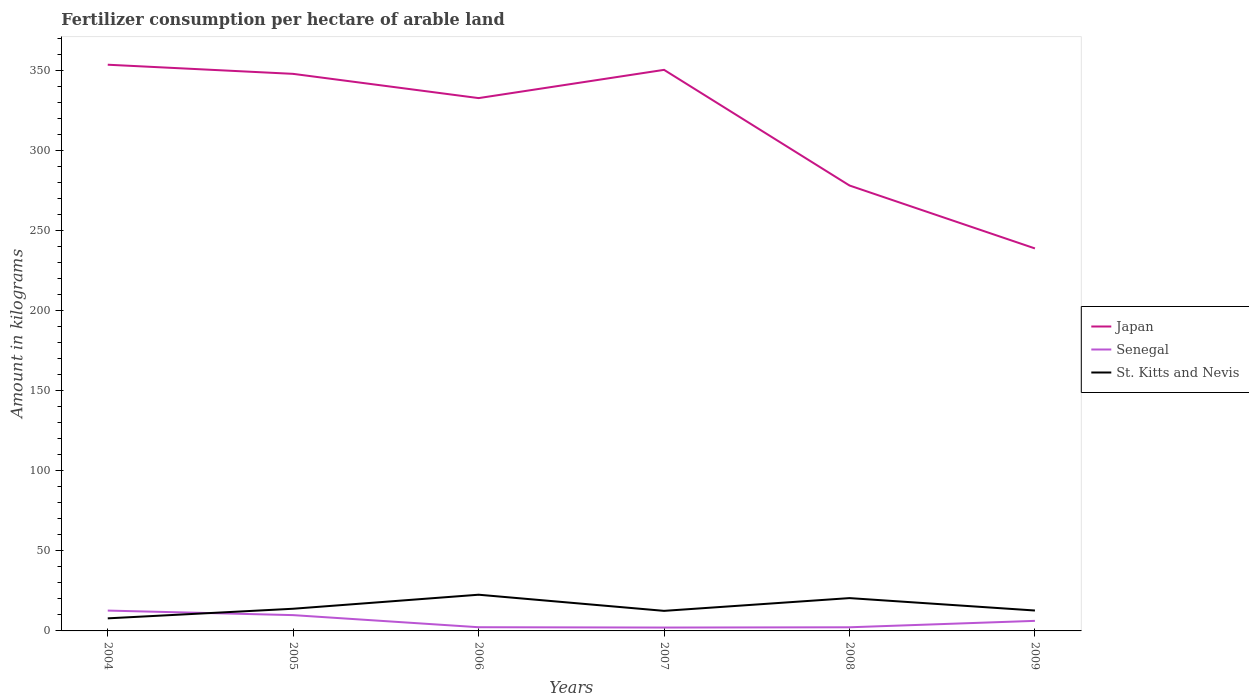Does the line corresponding to Japan intersect with the line corresponding to St. Kitts and Nevis?
Offer a very short reply. No. Across all years, what is the maximum amount of fertilizer consumption in Senegal?
Keep it short and to the point. 2.11. What is the total amount of fertilizer consumption in Senegal in the graph?
Offer a terse response. 3.58. What is the difference between the highest and the second highest amount of fertilizer consumption in St. Kitts and Nevis?
Your answer should be very brief. 14.76. How many years are there in the graph?
Your response must be concise. 6. What is the difference between two consecutive major ticks on the Y-axis?
Ensure brevity in your answer.  50. Are the values on the major ticks of Y-axis written in scientific E-notation?
Provide a succinct answer. No. Where does the legend appear in the graph?
Keep it short and to the point. Center right. How many legend labels are there?
Offer a very short reply. 3. What is the title of the graph?
Provide a succinct answer. Fertilizer consumption per hectare of arable land. Does "Chad" appear as one of the legend labels in the graph?
Keep it short and to the point. No. What is the label or title of the Y-axis?
Keep it short and to the point. Amount in kilograms. What is the Amount in kilograms of Japan in 2004?
Your answer should be compact. 353.68. What is the Amount in kilograms in Senegal in 2004?
Give a very brief answer. 12.71. What is the Amount in kilograms of St. Kitts and Nevis in 2004?
Give a very brief answer. 7.86. What is the Amount in kilograms of Japan in 2005?
Your answer should be very brief. 347.97. What is the Amount in kilograms in Senegal in 2005?
Your answer should be very brief. 9.87. What is the Amount in kilograms in St. Kitts and Nevis in 2005?
Keep it short and to the point. 13.85. What is the Amount in kilograms in Japan in 2006?
Your response must be concise. 332.83. What is the Amount in kilograms in Senegal in 2006?
Keep it short and to the point. 2.31. What is the Amount in kilograms in St. Kitts and Nevis in 2006?
Give a very brief answer. 22.61. What is the Amount in kilograms in Japan in 2007?
Ensure brevity in your answer.  350.47. What is the Amount in kilograms of Senegal in 2007?
Provide a short and direct response. 2.11. What is the Amount in kilograms in St. Kitts and Nevis in 2007?
Your answer should be very brief. 12.53. What is the Amount in kilograms in Japan in 2008?
Keep it short and to the point. 278.23. What is the Amount in kilograms of Senegal in 2008?
Give a very brief answer. 2.27. What is the Amount in kilograms of Japan in 2009?
Provide a succinct answer. 238.93. What is the Amount in kilograms in Senegal in 2009?
Give a very brief answer. 6.29. What is the Amount in kilograms of St. Kitts and Nevis in 2009?
Keep it short and to the point. 12.75. Across all years, what is the maximum Amount in kilograms of Japan?
Provide a succinct answer. 353.68. Across all years, what is the maximum Amount in kilograms in Senegal?
Your response must be concise. 12.71. Across all years, what is the maximum Amount in kilograms of St. Kitts and Nevis?
Make the answer very short. 22.61. Across all years, what is the minimum Amount in kilograms in Japan?
Make the answer very short. 238.93. Across all years, what is the minimum Amount in kilograms of Senegal?
Ensure brevity in your answer.  2.11. Across all years, what is the minimum Amount in kilograms in St. Kitts and Nevis?
Keep it short and to the point. 7.86. What is the total Amount in kilograms of Japan in the graph?
Your response must be concise. 1902.11. What is the total Amount in kilograms in Senegal in the graph?
Provide a short and direct response. 35.56. What is the total Amount in kilograms in St. Kitts and Nevis in the graph?
Your answer should be compact. 90.11. What is the difference between the Amount in kilograms of Japan in 2004 and that in 2005?
Provide a succinct answer. 5.71. What is the difference between the Amount in kilograms in Senegal in 2004 and that in 2005?
Give a very brief answer. 2.85. What is the difference between the Amount in kilograms in St. Kitts and Nevis in 2004 and that in 2005?
Ensure brevity in your answer.  -6. What is the difference between the Amount in kilograms of Japan in 2004 and that in 2006?
Make the answer very short. 20.86. What is the difference between the Amount in kilograms of Senegal in 2004 and that in 2006?
Provide a short and direct response. 10.4. What is the difference between the Amount in kilograms in St. Kitts and Nevis in 2004 and that in 2006?
Make the answer very short. -14.76. What is the difference between the Amount in kilograms in Japan in 2004 and that in 2007?
Offer a terse response. 3.21. What is the difference between the Amount in kilograms of Senegal in 2004 and that in 2007?
Provide a succinct answer. 10.6. What is the difference between the Amount in kilograms in St. Kitts and Nevis in 2004 and that in 2007?
Give a very brief answer. -4.67. What is the difference between the Amount in kilograms in Japan in 2004 and that in 2008?
Your answer should be compact. 75.46. What is the difference between the Amount in kilograms of Senegal in 2004 and that in 2008?
Offer a terse response. 10.44. What is the difference between the Amount in kilograms in St. Kitts and Nevis in 2004 and that in 2008?
Provide a succinct answer. -12.64. What is the difference between the Amount in kilograms in Japan in 2004 and that in 2009?
Offer a terse response. 114.76. What is the difference between the Amount in kilograms of Senegal in 2004 and that in 2009?
Your answer should be very brief. 6.42. What is the difference between the Amount in kilograms in St. Kitts and Nevis in 2004 and that in 2009?
Make the answer very short. -4.89. What is the difference between the Amount in kilograms in Japan in 2005 and that in 2006?
Give a very brief answer. 15.14. What is the difference between the Amount in kilograms in Senegal in 2005 and that in 2006?
Give a very brief answer. 7.56. What is the difference between the Amount in kilograms in St. Kitts and Nevis in 2005 and that in 2006?
Your answer should be very brief. -8.76. What is the difference between the Amount in kilograms in Japan in 2005 and that in 2007?
Offer a terse response. -2.51. What is the difference between the Amount in kilograms in Senegal in 2005 and that in 2007?
Give a very brief answer. 7.76. What is the difference between the Amount in kilograms in St. Kitts and Nevis in 2005 and that in 2007?
Your answer should be compact. 1.32. What is the difference between the Amount in kilograms of Japan in 2005 and that in 2008?
Your response must be concise. 69.74. What is the difference between the Amount in kilograms in Senegal in 2005 and that in 2008?
Provide a short and direct response. 7.59. What is the difference between the Amount in kilograms in St. Kitts and Nevis in 2005 and that in 2008?
Your response must be concise. -6.65. What is the difference between the Amount in kilograms of Japan in 2005 and that in 2009?
Offer a very short reply. 109.04. What is the difference between the Amount in kilograms of Senegal in 2005 and that in 2009?
Provide a succinct answer. 3.58. What is the difference between the Amount in kilograms in St. Kitts and Nevis in 2005 and that in 2009?
Make the answer very short. 1.1. What is the difference between the Amount in kilograms of Japan in 2006 and that in 2007?
Ensure brevity in your answer.  -17.65. What is the difference between the Amount in kilograms of Senegal in 2006 and that in 2007?
Offer a terse response. 0.2. What is the difference between the Amount in kilograms in St. Kitts and Nevis in 2006 and that in 2007?
Your response must be concise. 10.08. What is the difference between the Amount in kilograms of Japan in 2006 and that in 2008?
Offer a terse response. 54.6. What is the difference between the Amount in kilograms of Senegal in 2006 and that in 2008?
Your answer should be compact. 0.04. What is the difference between the Amount in kilograms of St. Kitts and Nevis in 2006 and that in 2008?
Make the answer very short. 2.11. What is the difference between the Amount in kilograms of Japan in 2006 and that in 2009?
Offer a terse response. 93.9. What is the difference between the Amount in kilograms in Senegal in 2006 and that in 2009?
Provide a short and direct response. -3.98. What is the difference between the Amount in kilograms in St. Kitts and Nevis in 2006 and that in 2009?
Offer a very short reply. 9.86. What is the difference between the Amount in kilograms of Japan in 2007 and that in 2008?
Your response must be concise. 72.25. What is the difference between the Amount in kilograms of Senegal in 2007 and that in 2008?
Provide a short and direct response. -0.16. What is the difference between the Amount in kilograms in St. Kitts and Nevis in 2007 and that in 2008?
Offer a very short reply. -7.97. What is the difference between the Amount in kilograms of Japan in 2007 and that in 2009?
Your answer should be very brief. 111.55. What is the difference between the Amount in kilograms in Senegal in 2007 and that in 2009?
Your answer should be compact. -4.18. What is the difference between the Amount in kilograms in St. Kitts and Nevis in 2007 and that in 2009?
Offer a very short reply. -0.22. What is the difference between the Amount in kilograms of Japan in 2008 and that in 2009?
Provide a succinct answer. 39.3. What is the difference between the Amount in kilograms of Senegal in 2008 and that in 2009?
Ensure brevity in your answer.  -4.02. What is the difference between the Amount in kilograms of St. Kitts and Nevis in 2008 and that in 2009?
Your answer should be compact. 7.75. What is the difference between the Amount in kilograms of Japan in 2004 and the Amount in kilograms of Senegal in 2005?
Keep it short and to the point. 343.82. What is the difference between the Amount in kilograms in Japan in 2004 and the Amount in kilograms in St. Kitts and Nevis in 2005?
Your answer should be compact. 339.83. What is the difference between the Amount in kilograms in Senegal in 2004 and the Amount in kilograms in St. Kitts and Nevis in 2005?
Give a very brief answer. -1.14. What is the difference between the Amount in kilograms of Japan in 2004 and the Amount in kilograms of Senegal in 2006?
Your answer should be compact. 351.37. What is the difference between the Amount in kilograms in Japan in 2004 and the Amount in kilograms in St. Kitts and Nevis in 2006?
Make the answer very short. 331.07. What is the difference between the Amount in kilograms of Senegal in 2004 and the Amount in kilograms of St. Kitts and Nevis in 2006?
Make the answer very short. -9.9. What is the difference between the Amount in kilograms in Japan in 2004 and the Amount in kilograms in Senegal in 2007?
Give a very brief answer. 351.57. What is the difference between the Amount in kilograms of Japan in 2004 and the Amount in kilograms of St. Kitts and Nevis in 2007?
Provide a short and direct response. 341.15. What is the difference between the Amount in kilograms in Senegal in 2004 and the Amount in kilograms in St. Kitts and Nevis in 2007?
Offer a terse response. 0.18. What is the difference between the Amount in kilograms of Japan in 2004 and the Amount in kilograms of Senegal in 2008?
Your answer should be compact. 351.41. What is the difference between the Amount in kilograms in Japan in 2004 and the Amount in kilograms in St. Kitts and Nevis in 2008?
Give a very brief answer. 333.18. What is the difference between the Amount in kilograms of Senegal in 2004 and the Amount in kilograms of St. Kitts and Nevis in 2008?
Your answer should be very brief. -7.79. What is the difference between the Amount in kilograms in Japan in 2004 and the Amount in kilograms in Senegal in 2009?
Offer a terse response. 347.39. What is the difference between the Amount in kilograms of Japan in 2004 and the Amount in kilograms of St. Kitts and Nevis in 2009?
Your response must be concise. 340.93. What is the difference between the Amount in kilograms of Senegal in 2004 and the Amount in kilograms of St. Kitts and Nevis in 2009?
Ensure brevity in your answer.  -0.04. What is the difference between the Amount in kilograms of Japan in 2005 and the Amount in kilograms of Senegal in 2006?
Your answer should be very brief. 345.66. What is the difference between the Amount in kilograms in Japan in 2005 and the Amount in kilograms in St. Kitts and Nevis in 2006?
Your answer should be very brief. 325.36. What is the difference between the Amount in kilograms in Senegal in 2005 and the Amount in kilograms in St. Kitts and Nevis in 2006?
Provide a short and direct response. -12.75. What is the difference between the Amount in kilograms in Japan in 2005 and the Amount in kilograms in Senegal in 2007?
Make the answer very short. 345.86. What is the difference between the Amount in kilograms in Japan in 2005 and the Amount in kilograms in St. Kitts and Nevis in 2007?
Make the answer very short. 335.44. What is the difference between the Amount in kilograms in Senegal in 2005 and the Amount in kilograms in St. Kitts and Nevis in 2007?
Your answer should be compact. -2.67. What is the difference between the Amount in kilograms of Japan in 2005 and the Amount in kilograms of Senegal in 2008?
Your response must be concise. 345.7. What is the difference between the Amount in kilograms in Japan in 2005 and the Amount in kilograms in St. Kitts and Nevis in 2008?
Offer a very short reply. 327.47. What is the difference between the Amount in kilograms in Senegal in 2005 and the Amount in kilograms in St. Kitts and Nevis in 2008?
Make the answer very short. -10.63. What is the difference between the Amount in kilograms in Japan in 2005 and the Amount in kilograms in Senegal in 2009?
Give a very brief answer. 341.68. What is the difference between the Amount in kilograms in Japan in 2005 and the Amount in kilograms in St. Kitts and Nevis in 2009?
Provide a succinct answer. 335.22. What is the difference between the Amount in kilograms of Senegal in 2005 and the Amount in kilograms of St. Kitts and Nevis in 2009?
Offer a very short reply. -2.88. What is the difference between the Amount in kilograms in Japan in 2006 and the Amount in kilograms in Senegal in 2007?
Keep it short and to the point. 330.72. What is the difference between the Amount in kilograms in Japan in 2006 and the Amount in kilograms in St. Kitts and Nevis in 2007?
Offer a very short reply. 320.3. What is the difference between the Amount in kilograms in Senegal in 2006 and the Amount in kilograms in St. Kitts and Nevis in 2007?
Offer a terse response. -10.22. What is the difference between the Amount in kilograms in Japan in 2006 and the Amount in kilograms in Senegal in 2008?
Make the answer very short. 330.56. What is the difference between the Amount in kilograms of Japan in 2006 and the Amount in kilograms of St. Kitts and Nevis in 2008?
Give a very brief answer. 312.33. What is the difference between the Amount in kilograms of Senegal in 2006 and the Amount in kilograms of St. Kitts and Nevis in 2008?
Keep it short and to the point. -18.19. What is the difference between the Amount in kilograms of Japan in 2006 and the Amount in kilograms of Senegal in 2009?
Your response must be concise. 326.54. What is the difference between the Amount in kilograms in Japan in 2006 and the Amount in kilograms in St. Kitts and Nevis in 2009?
Make the answer very short. 320.08. What is the difference between the Amount in kilograms in Senegal in 2006 and the Amount in kilograms in St. Kitts and Nevis in 2009?
Make the answer very short. -10.44. What is the difference between the Amount in kilograms of Japan in 2007 and the Amount in kilograms of Senegal in 2008?
Offer a terse response. 348.2. What is the difference between the Amount in kilograms of Japan in 2007 and the Amount in kilograms of St. Kitts and Nevis in 2008?
Make the answer very short. 329.97. What is the difference between the Amount in kilograms of Senegal in 2007 and the Amount in kilograms of St. Kitts and Nevis in 2008?
Provide a succinct answer. -18.39. What is the difference between the Amount in kilograms of Japan in 2007 and the Amount in kilograms of Senegal in 2009?
Your answer should be compact. 344.19. What is the difference between the Amount in kilograms of Japan in 2007 and the Amount in kilograms of St. Kitts and Nevis in 2009?
Make the answer very short. 337.72. What is the difference between the Amount in kilograms of Senegal in 2007 and the Amount in kilograms of St. Kitts and Nevis in 2009?
Provide a short and direct response. -10.64. What is the difference between the Amount in kilograms of Japan in 2008 and the Amount in kilograms of Senegal in 2009?
Keep it short and to the point. 271.94. What is the difference between the Amount in kilograms of Japan in 2008 and the Amount in kilograms of St. Kitts and Nevis in 2009?
Your response must be concise. 265.48. What is the difference between the Amount in kilograms in Senegal in 2008 and the Amount in kilograms in St. Kitts and Nevis in 2009?
Make the answer very short. -10.48. What is the average Amount in kilograms in Japan per year?
Your answer should be compact. 317.02. What is the average Amount in kilograms in Senegal per year?
Keep it short and to the point. 5.93. What is the average Amount in kilograms in St. Kitts and Nevis per year?
Your response must be concise. 15.02. In the year 2004, what is the difference between the Amount in kilograms of Japan and Amount in kilograms of Senegal?
Provide a short and direct response. 340.97. In the year 2004, what is the difference between the Amount in kilograms in Japan and Amount in kilograms in St. Kitts and Nevis?
Provide a short and direct response. 345.83. In the year 2004, what is the difference between the Amount in kilograms of Senegal and Amount in kilograms of St. Kitts and Nevis?
Your answer should be compact. 4.85. In the year 2005, what is the difference between the Amount in kilograms in Japan and Amount in kilograms in Senegal?
Give a very brief answer. 338.1. In the year 2005, what is the difference between the Amount in kilograms of Japan and Amount in kilograms of St. Kitts and Nevis?
Your answer should be compact. 334.12. In the year 2005, what is the difference between the Amount in kilograms in Senegal and Amount in kilograms in St. Kitts and Nevis?
Ensure brevity in your answer.  -3.99. In the year 2006, what is the difference between the Amount in kilograms in Japan and Amount in kilograms in Senegal?
Offer a terse response. 330.52. In the year 2006, what is the difference between the Amount in kilograms in Japan and Amount in kilograms in St. Kitts and Nevis?
Provide a succinct answer. 310.21. In the year 2006, what is the difference between the Amount in kilograms of Senegal and Amount in kilograms of St. Kitts and Nevis?
Keep it short and to the point. -20.3. In the year 2007, what is the difference between the Amount in kilograms of Japan and Amount in kilograms of Senegal?
Offer a very short reply. 348.37. In the year 2007, what is the difference between the Amount in kilograms in Japan and Amount in kilograms in St. Kitts and Nevis?
Offer a terse response. 337.94. In the year 2007, what is the difference between the Amount in kilograms of Senegal and Amount in kilograms of St. Kitts and Nevis?
Your answer should be compact. -10.42. In the year 2008, what is the difference between the Amount in kilograms in Japan and Amount in kilograms in Senegal?
Provide a short and direct response. 275.96. In the year 2008, what is the difference between the Amount in kilograms in Japan and Amount in kilograms in St. Kitts and Nevis?
Your answer should be very brief. 257.73. In the year 2008, what is the difference between the Amount in kilograms of Senegal and Amount in kilograms of St. Kitts and Nevis?
Your response must be concise. -18.23. In the year 2009, what is the difference between the Amount in kilograms of Japan and Amount in kilograms of Senegal?
Offer a terse response. 232.64. In the year 2009, what is the difference between the Amount in kilograms of Japan and Amount in kilograms of St. Kitts and Nevis?
Provide a short and direct response. 226.18. In the year 2009, what is the difference between the Amount in kilograms of Senegal and Amount in kilograms of St. Kitts and Nevis?
Give a very brief answer. -6.46. What is the ratio of the Amount in kilograms in Japan in 2004 to that in 2005?
Keep it short and to the point. 1.02. What is the ratio of the Amount in kilograms in Senegal in 2004 to that in 2005?
Your answer should be compact. 1.29. What is the ratio of the Amount in kilograms in St. Kitts and Nevis in 2004 to that in 2005?
Your response must be concise. 0.57. What is the ratio of the Amount in kilograms of Japan in 2004 to that in 2006?
Your answer should be compact. 1.06. What is the ratio of the Amount in kilograms in Senegal in 2004 to that in 2006?
Provide a succinct answer. 5.51. What is the ratio of the Amount in kilograms of St. Kitts and Nevis in 2004 to that in 2006?
Keep it short and to the point. 0.35. What is the ratio of the Amount in kilograms of Japan in 2004 to that in 2007?
Offer a very short reply. 1.01. What is the ratio of the Amount in kilograms in Senegal in 2004 to that in 2007?
Provide a short and direct response. 6.03. What is the ratio of the Amount in kilograms of St. Kitts and Nevis in 2004 to that in 2007?
Your answer should be very brief. 0.63. What is the ratio of the Amount in kilograms of Japan in 2004 to that in 2008?
Provide a succinct answer. 1.27. What is the ratio of the Amount in kilograms in Senegal in 2004 to that in 2008?
Your answer should be compact. 5.6. What is the ratio of the Amount in kilograms of St. Kitts and Nevis in 2004 to that in 2008?
Your response must be concise. 0.38. What is the ratio of the Amount in kilograms in Japan in 2004 to that in 2009?
Make the answer very short. 1.48. What is the ratio of the Amount in kilograms of Senegal in 2004 to that in 2009?
Provide a short and direct response. 2.02. What is the ratio of the Amount in kilograms of St. Kitts and Nevis in 2004 to that in 2009?
Your answer should be compact. 0.62. What is the ratio of the Amount in kilograms in Japan in 2005 to that in 2006?
Offer a very short reply. 1.05. What is the ratio of the Amount in kilograms in Senegal in 2005 to that in 2006?
Provide a succinct answer. 4.27. What is the ratio of the Amount in kilograms of St. Kitts and Nevis in 2005 to that in 2006?
Offer a very short reply. 0.61. What is the ratio of the Amount in kilograms of Senegal in 2005 to that in 2007?
Give a very brief answer. 4.68. What is the ratio of the Amount in kilograms of St. Kitts and Nevis in 2005 to that in 2007?
Make the answer very short. 1.11. What is the ratio of the Amount in kilograms in Japan in 2005 to that in 2008?
Give a very brief answer. 1.25. What is the ratio of the Amount in kilograms in Senegal in 2005 to that in 2008?
Provide a short and direct response. 4.34. What is the ratio of the Amount in kilograms in St. Kitts and Nevis in 2005 to that in 2008?
Keep it short and to the point. 0.68. What is the ratio of the Amount in kilograms in Japan in 2005 to that in 2009?
Make the answer very short. 1.46. What is the ratio of the Amount in kilograms of Senegal in 2005 to that in 2009?
Ensure brevity in your answer.  1.57. What is the ratio of the Amount in kilograms of St. Kitts and Nevis in 2005 to that in 2009?
Provide a short and direct response. 1.09. What is the ratio of the Amount in kilograms of Japan in 2006 to that in 2007?
Make the answer very short. 0.95. What is the ratio of the Amount in kilograms of Senegal in 2006 to that in 2007?
Make the answer very short. 1.09. What is the ratio of the Amount in kilograms in St. Kitts and Nevis in 2006 to that in 2007?
Provide a short and direct response. 1.8. What is the ratio of the Amount in kilograms in Japan in 2006 to that in 2008?
Offer a very short reply. 1.2. What is the ratio of the Amount in kilograms in Senegal in 2006 to that in 2008?
Your answer should be compact. 1.02. What is the ratio of the Amount in kilograms in St. Kitts and Nevis in 2006 to that in 2008?
Offer a very short reply. 1.1. What is the ratio of the Amount in kilograms of Japan in 2006 to that in 2009?
Keep it short and to the point. 1.39. What is the ratio of the Amount in kilograms of Senegal in 2006 to that in 2009?
Make the answer very short. 0.37. What is the ratio of the Amount in kilograms of St. Kitts and Nevis in 2006 to that in 2009?
Offer a very short reply. 1.77. What is the ratio of the Amount in kilograms in Japan in 2007 to that in 2008?
Offer a terse response. 1.26. What is the ratio of the Amount in kilograms of Senegal in 2007 to that in 2008?
Make the answer very short. 0.93. What is the ratio of the Amount in kilograms of St. Kitts and Nevis in 2007 to that in 2008?
Offer a terse response. 0.61. What is the ratio of the Amount in kilograms in Japan in 2007 to that in 2009?
Your answer should be compact. 1.47. What is the ratio of the Amount in kilograms of Senegal in 2007 to that in 2009?
Offer a very short reply. 0.34. What is the ratio of the Amount in kilograms in St. Kitts and Nevis in 2007 to that in 2009?
Your answer should be very brief. 0.98. What is the ratio of the Amount in kilograms of Japan in 2008 to that in 2009?
Your answer should be compact. 1.16. What is the ratio of the Amount in kilograms in Senegal in 2008 to that in 2009?
Your answer should be compact. 0.36. What is the ratio of the Amount in kilograms of St. Kitts and Nevis in 2008 to that in 2009?
Offer a very short reply. 1.61. What is the difference between the highest and the second highest Amount in kilograms in Japan?
Your answer should be very brief. 3.21. What is the difference between the highest and the second highest Amount in kilograms of Senegal?
Provide a short and direct response. 2.85. What is the difference between the highest and the second highest Amount in kilograms in St. Kitts and Nevis?
Ensure brevity in your answer.  2.11. What is the difference between the highest and the lowest Amount in kilograms of Japan?
Your answer should be very brief. 114.76. What is the difference between the highest and the lowest Amount in kilograms of Senegal?
Keep it short and to the point. 10.6. What is the difference between the highest and the lowest Amount in kilograms in St. Kitts and Nevis?
Make the answer very short. 14.76. 